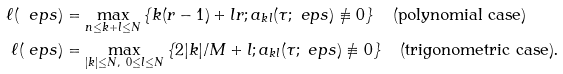Convert formula to latex. <formula><loc_0><loc_0><loc_500><loc_500>\ell ( \ e p s ) & = \max _ { n \leq k + l \leq N } \left \{ k ( r - 1 ) + l r ; a _ { k l } ( \tau ; \ e p s ) \not \equiv 0 \right \} \quad \text {(polynomial case)} \\ \ell ( \ e p s ) & = \max _ { | k | \leq N , \ 0 \leq l \leq N } \left \{ 2 | k | / M + l ; a _ { k l } ( \tau ; \ e p s ) \not \equiv 0 \right \} \quad \text {(trigonometric case).}</formula> 